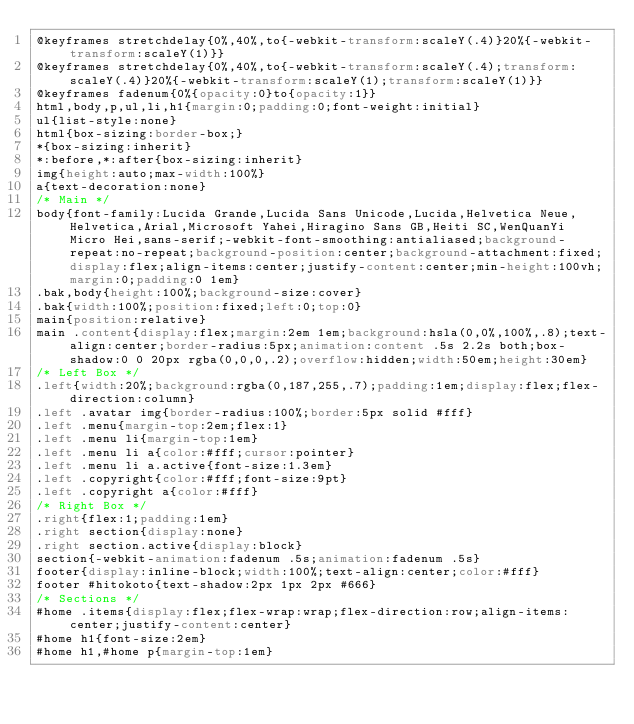<code> <loc_0><loc_0><loc_500><loc_500><_CSS_>@keyframes stretchdelay{0%,40%,to{-webkit-transform:scaleY(.4)}20%{-webkit-transform:scaleY(1)}}
@keyframes stretchdelay{0%,40%,to{-webkit-transform:scaleY(.4);transform:scaleY(.4)}20%{-webkit-transform:scaleY(1);transform:scaleY(1)}}
@keyframes fadenum{0%{opacity:0}to{opacity:1}}
html,body,p,ul,li,h1{margin:0;padding:0;font-weight:initial}
ul{list-style:none}
html{box-sizing:border-box;}
*{box-sizing:inherit}
*:before,*:after{box-sizing:inherit}
img{height:auto;max-width:100%}
a{text-decoration:none}
/* Main */
body{font-family:Lucida Grande,Lucida Sans Unicode,Lucida,Helvetica Neue,Helvetica,Arial,Microsoft Yahei,Hiragino Sans GB,Heiti SC,WenQuanYi Micro Hei,sans-serif;-webkit-font-smoothing:antialiased;background-repeat:no-repeat;background-position:center;background-attachment:fixed;display:flex;align-items:center;justify-content:center;min-height:100vh;margin:0;padding:0 1em}
.bak,body{height:100%;background-size:cover}
.bak{width:100%;position:fixed;left:0;top:0}
main{position:relative}
main .content{display:flex;margin:2em 1em;background:hsla(0,0%,100%,.8);text-align:center;border-radius:5px;animation:content .5s 2.2s both;box-shadow:0 0 20px rgba(0,0,0,.2);overflow:hidden;width:50em;height:30em}
/* Left Box */
.left{width:20%;background:rgba(0,187,255,.7);padding:1em;display:flex;flex-direction:column}
.left .avatar img{border-radius:100%;border:5px solid #fff}
.left .menu{margin-top:2em;flex:1}
.left .menu li{margin-top:1em}
.left .menu li a{color:#fff;cursor:pointer}
.left .menu li a.active{font-size:1.3em}
.left .copyright{color:#fff;font-size:9pt}
.left .copyright a{color:#fff}
/* Right Box */
.right{flex:1;padding:1em}
.right section{display:none}
.right section.active{display:block}
section{-webkit-animation:fadenum .5s;animation:fadenum .5s}
footer{display:inline-block;width:100%;text-align:center;color:#fff}
footer #hitokoto{text-shadow:2px 1px 2px #666}
/* Sections */
#home .items{display:flex;flex-wrap:wrap;flex-direction:row;align-items:center;justify-content:center}
#home h1{font-size:2em}
#home h1,#home p{margin-top:1em}</code> 